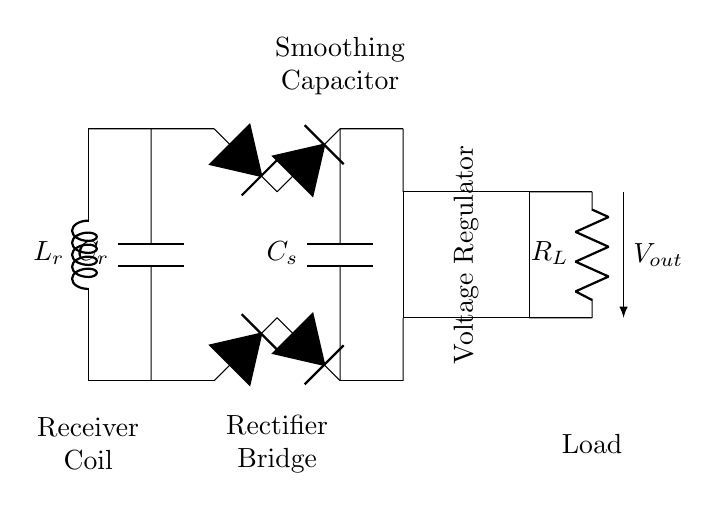What type of coil is shown in the circuit? The circuit diagram shows a receiver coil, which is indicated clearly at the beginning of the circuit. It is used for inductive charging.
Answer: Receiver Coil What component is responsible for rectifying the AC voltage? The rectifier bridge, which consists of four diodes arranged in a specific pattern, converts the alternating current from the coil to direct current.
Answer: Rectifier Bridge What is the role of the smoothing capacitor in the circuit? The smoothing capacitor, labeled as C_s, is located after the rectifier. It serves to smooth out the fluctuations in the output voltage, providing a more stable DC voltage to the load.
Answer: Smoothing Capacitor How many diodes are in the rectifier bridge? The rectifier bridge contains four diodes, as seen in the labeled diagram where each diode connects to different points of the AC input.
Answer: Four What is the function of the voltage regulator in this circuit? The voltage regulator ensures the output voltage remains constant, regardless of variations in input voltage or load conditions. It stabilizes the voltage for the connected load.
Answer: Voltage Regulator Which component directly connects to the load in the diagram? The load, represented as R_L, is connected directly to the output of the voltage regulator via two short connections.
Answer: Load What happens to the current after it passes through the smoothing capacitor? After passing through the smoothing capacitor, the current becomes more stable and consistent due to the capacitor's ability to store charge and release it as needed.
Answer: More stable current 